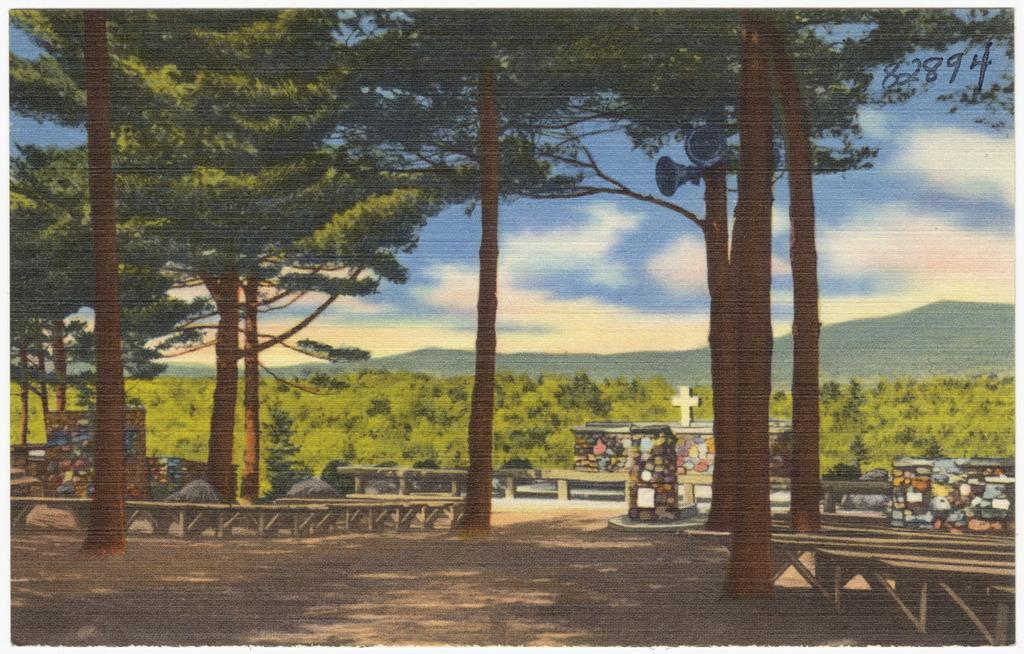What type of natural elements can be seen in the image? There are trees in the image. What part of the natural environment is visible in the image? The sky is visible at the top of the image. What man-made objects are present in the image? There are loudspeakers in the image. How are the loudspeakers positioned in the image? The loudspeakers are connected to a tree. What is the medium of the image? The image is painted. Can you see any scissors being used to cut the tree in the image? No, there are no scissors or any cutting activity depicted in the image. What type of seed is being planted near the tree in the image? There is no seed or planting activity shown in the image; it only features trees, loudspeakers, and the sky. 